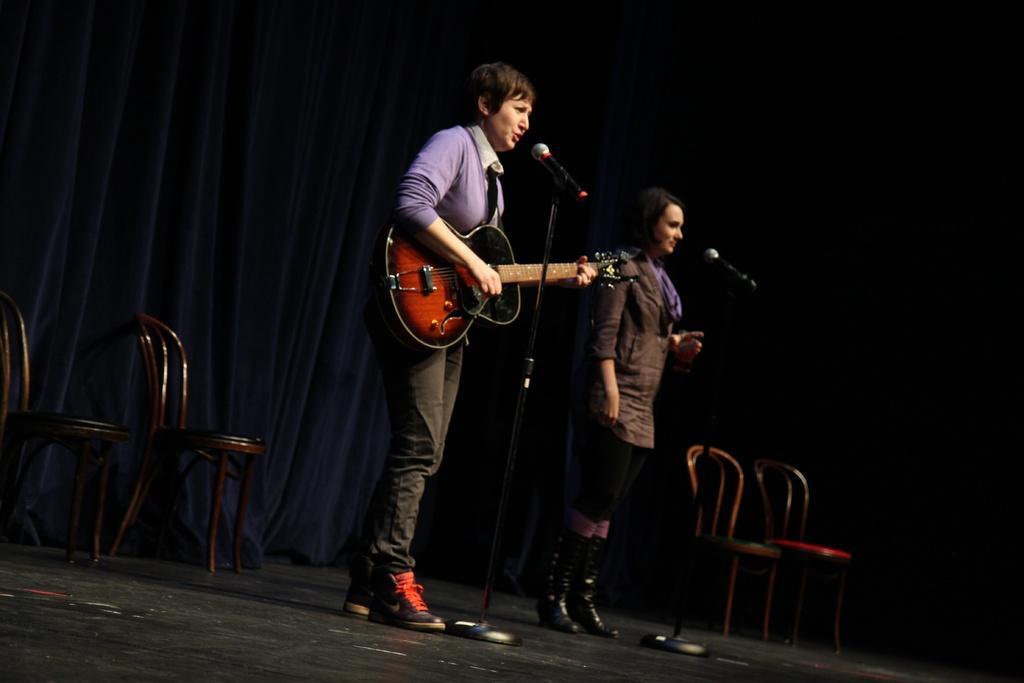How would you summarize this image in a sentence or two? Her we can see a woman standing on the stage, and singing and holding a guitar in her hands, and at side a woman is standing,and in front there is microphone, and at back there are chairs. 